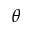<formula> <loc_0><loc_0><loc_500><loc_500>\theta</formula> 